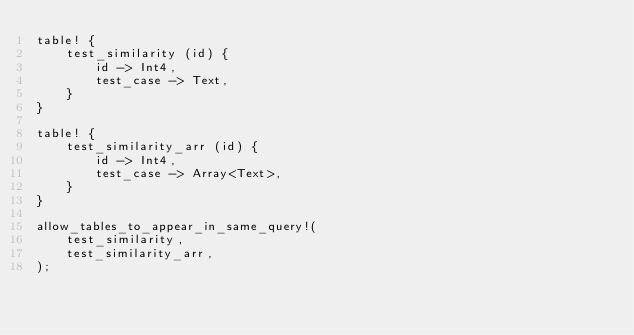Convert code to text. <code><loc_0><loc_0><loc_500><loc_500><_Rust_>table! {
    test_similarity (id) {
        id -> Int4,
        test_case -> Text,
    }
}

table! {
    test_similarity_arr (id) {
        id -> Int4,
        test_case -> Array<Text>,
    }
}

allow_tables_to_appear_in_same_query!(
    test_similarity,
    test_similarity_arr,
);
</code> 